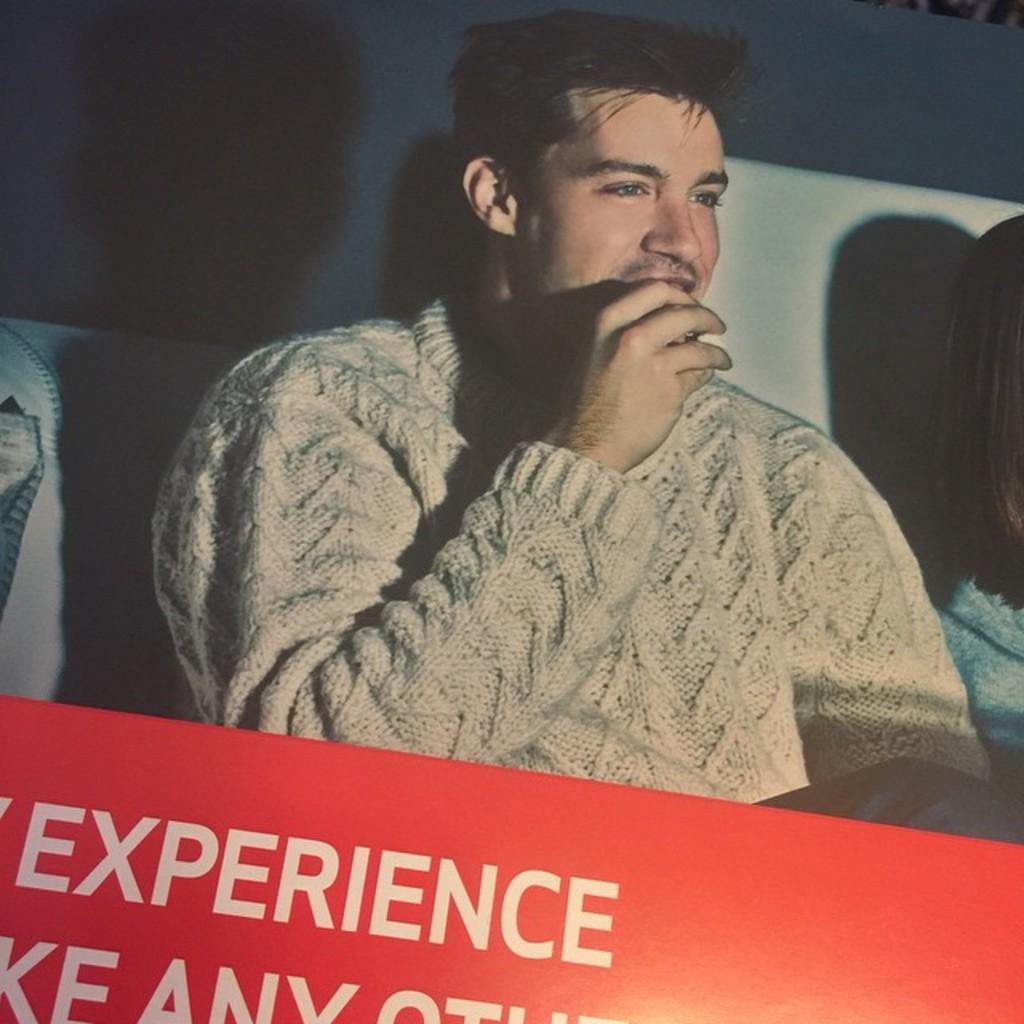What is the main subject of the image? There is a picture of a person in the image. Is there any text associated with the image? Yes, there is text at the bottom of the image. How fast is the representative running in the image? There is no representative or running depicted in the image; it features a picture of a person and text at the bottom. 